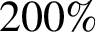<formula> <loc_0><loc_0><loc_500><loc_500>2 0 0 \%</formula> 